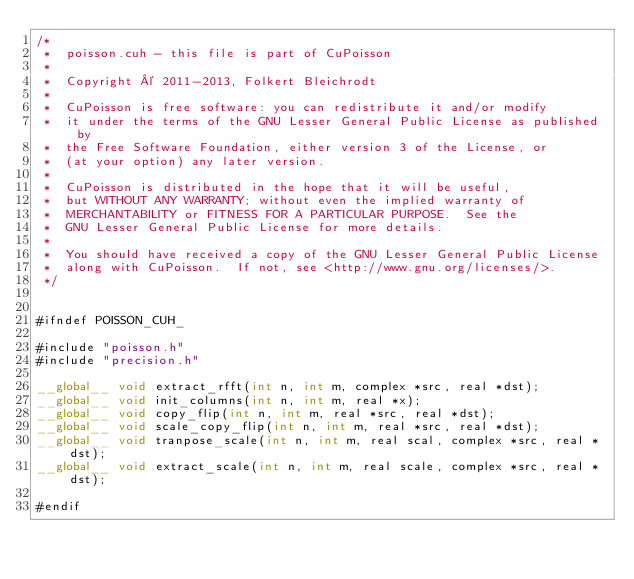<code> <loc_0><loc_0><loc_500><loc_500><_Cuda_>/* 
 *  poisson.cuh - this file is part of CuPoisson
 *
 *  Copyright © 2011-2013, Folkert Bleichrodt 
 *	
 *  CuPoisson is free software: you can redistribute it and/or modify
 *  it under the terms of the GNU Lesser General Public License as published by
 *  the Free Software Foundation, either version 3 of the License, or
 *  (at your option) any later version.
 *
 *  CuPoisson is distributed in the hope that it will be useful,
 *  but WITHOUT ANY WARRANTY; without even the implied warranty of
 *  MERCHANTABILITY or FITNESS FOR A PARTICULAR PURPOSE.  See the
 *  GNU Lesser General Public License for more details.
 *
 *  You should have received a copy of the GNU Lesser General Public License
 *  along with CuPoisson.  If not, see <http://www.gnu.org/licenses/>.
 */


#ifndef POISSON_CUH_

#include "poisson.h"
#include "precision.h"

__global__ void extract_rfft(int n, int m, complex *src, real *dst);
__global__ void init_columns(int n, int m, real *x);
__global__ void copy_flip(int n, int m, real *src, real *dst);
__global__ void scale_copy_flip(int n, int m, real *src, real *dst);
__global__ void tranpose_scale(int n, int m, real scal, complex *src, real *dst);
__global__ void extract_scale(int n, int m, real scale, complex *src, real *dst);

#endif
</code> 